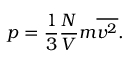<formula> <loc_0><loc_0><loc_500><loc_500>p = { \frac { 1 } { 3 } } { \frac { N } { V } } m { \overline { { v ^ { 2 } } } } .</formula> 